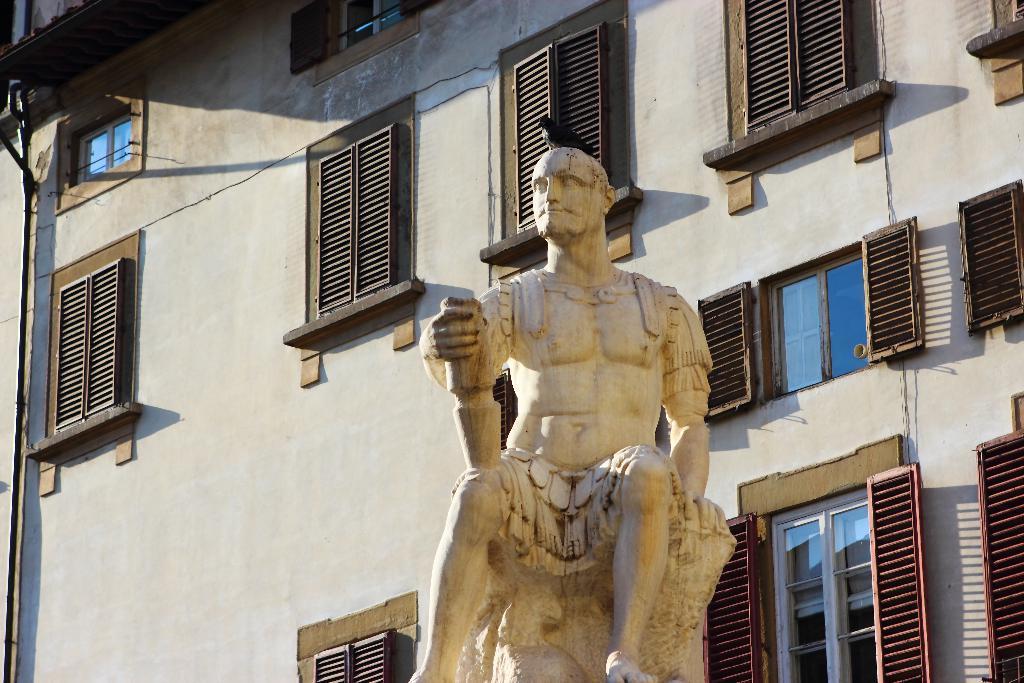Could you give a brief overview of what you see in this image? In this image there is a statue of a person sitting. Behind it there is a building having few windows. On the statue there is a bird. 